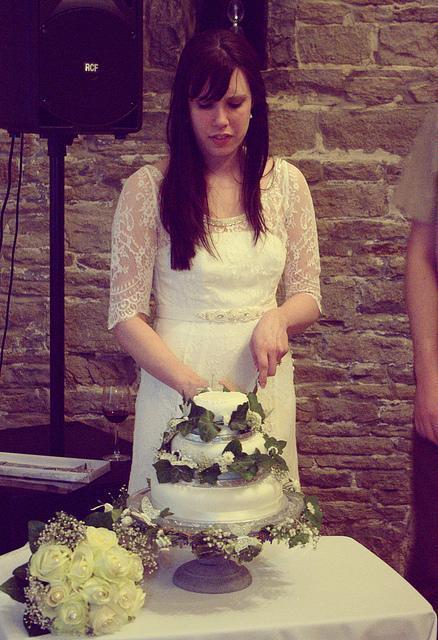How many people are there?
Give a very brief answer. 2. How many cakes can you see?
Give a very brief answer. 2. How many umbrellas are visible?
Give a very brief answer. 0. 